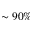<formula> <loc_0><loc_0><loc_500><loc_500>\sim 9 0 \%</formula> 